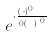<formula> <loc_0><loc_0><loc_500><loc_500>e ^ { \cdot \frac { ( F \cdot M ) ^ { 0 } } { 0 { ( s _ { F } ) } ^ { 0 } } }</formula> 